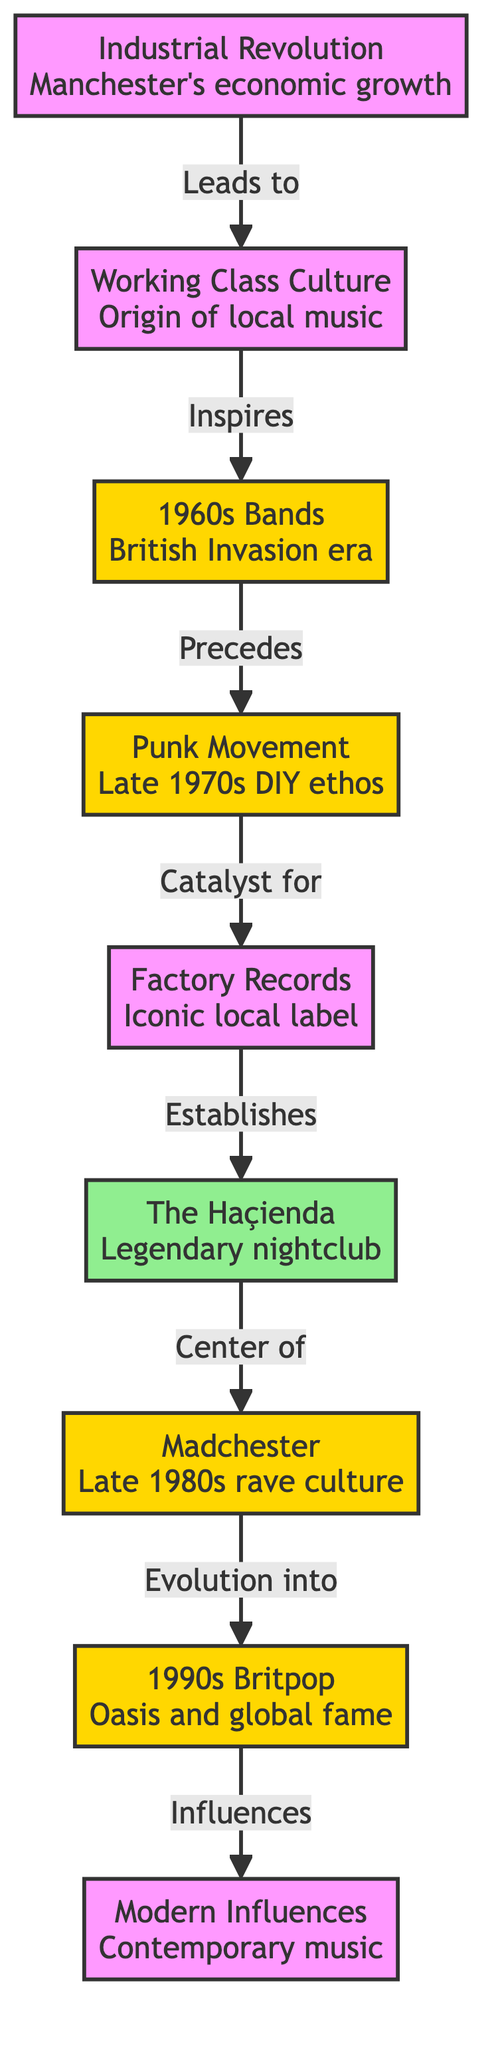what event led to the origin of local music in Manchester? The flowchart indicates that the Working Class Culture is the origin of local music in Manchester, and it's connected to the Industrial Revolution as the initial cause. Following the path from the Industrial Revolution to Working Class Culture affirms this relationship.
Answer: Working Class Culture how many different music eras are represented in the diagram? Counting the nodes labeled as eras gives us a total of five distinct music eras in the diagram: 1960s Bands, Punk Movement, Madchester, 1990s Britpop, and Modern Influences.
Answer: 5 which venue is established by Factory Records? According to the flowchart, Factory Records establishes the venue known as The Haçienda. This is directly depicted as a connection from Factory Records to The Haçienda in the diagram.
Answer: The Haçienda what cultural movement served as a catalyst for Factory Records? The flowchart shows that the Punk Movement serves as a catalyst for Factory Records, establishing a notable connection from the Punk Movement to Factory Records.
Answer: Punk Movement what significance does The Haçienda hold in the evolution of Manchester's music scene? The diagram indicates that The Haçienda is the center of Madchester, thus playing a critical role in the late 1980s rave culture, which is a significant moment in the evolution of Manchester's music scene.
Answer: Center of Madchester 